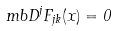Convert formula to latex. <formula><loc_0><loc_0><loc_500><loc_500>\ m b D ^ { j } F _ { j k } ( x ) = 0</formula> 